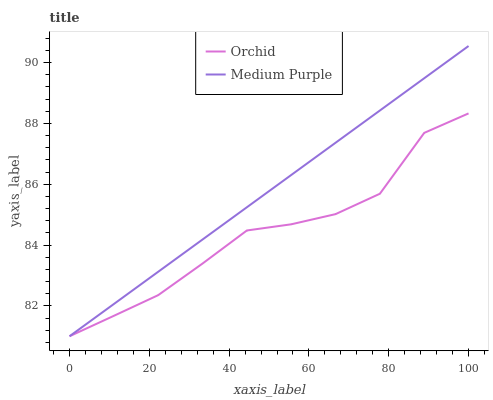Does Orchid have the minimum area under the curve?
Answer yes or no. Yes. Does Medium Purple have the maximum area under the curve?
Answer yes or no. Yes. Does Orchid have the maximum area under the curve?
Answer yes or no. No. Is Medium Purple the smoothest?
Answer yes or no. Yes. Is Orchid the roughest?
Answer yes or no. Yes. Is Orchid the smoothest?
Answer yes or no. No. Does Medium Purple have the lowest value?
Answer yes or no. Yes. Does Medium Purple have the highest value?
Answer yes or no. Yes. Does Orchid have the highest value?
Answer yes or no. No. Does Medium Purple intersect Orchid?
Answer yes or no. Yes. Is Medium Purple less than Orchid?
Answer yes or no. No. Is Medium Purple greater than Orchid?
Answer yes or no. No. 